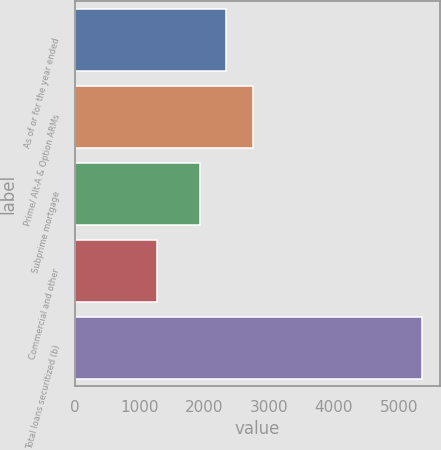<chart> <loc_0><loc_0><loc_500><loc_500><bar_chart><fcel>As of or for the year ended<fcel>Prime/ Alt-A & Option ARMs<fcel>Subprime mortgage<fcel>Commercial and other<fcel>Total loans securitized (b)<nl><fcel>2340.7<fcel>2750.4<fcel>1931<fcel>1267<fcel>5364<nl></chart> 